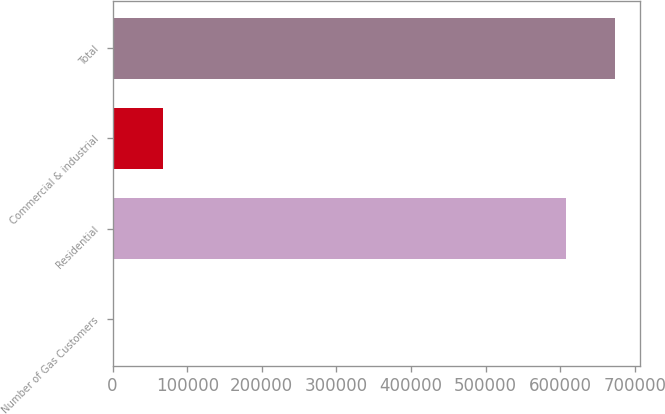<chart> <loc_0><loc_0><loc_500><loc_500><bar_chart><fcel>Number of Gas Customers<fcel>Residential<fcel>Commercial & industrial<fcel>Total<nl><fcel>2010<fcel>608553<fcel>67068.4<fcel>673611<nl></chart> 